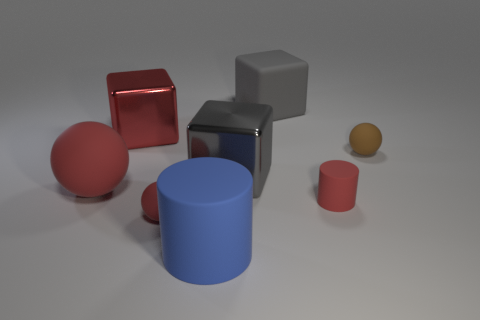What number of balls are either big brown objects or brown things?
Keep it short and to the point. 1. Is there anything else of the same color as the large cylinder?
Make the answer very short. No. There is a gray cube on the left side of the rubber object behind the brown thing; what is its material?
Ensure brevity in your answer.  Metal. Is the material of the tiny cylinder the same as the ball that is behind the large gray metal block?
Your response must be concise. Yes. How many objects are either rubber cylinders to the left of the gray matte cube or rubber blocks?
Your response must be concise. 2. Are there any rubber balls of the same color as the rubber block?
Your answer should be compact. No. Does the big blue matte object have the same shape as the big gray thing in front of the red metal block?
Keep it short and to the point. No. What number of blocks are both in front of the red cube and to the right of the gray shiny cube?
Give a very brief answer. 0. There is another large object that is the same shape as the brown object; what material is it?
Your answer should be compact. Rubber. There is a gray block right of the metallic object that is in front of the brown rubber thing; how big is it?
Your answer should be very brief. Large. 